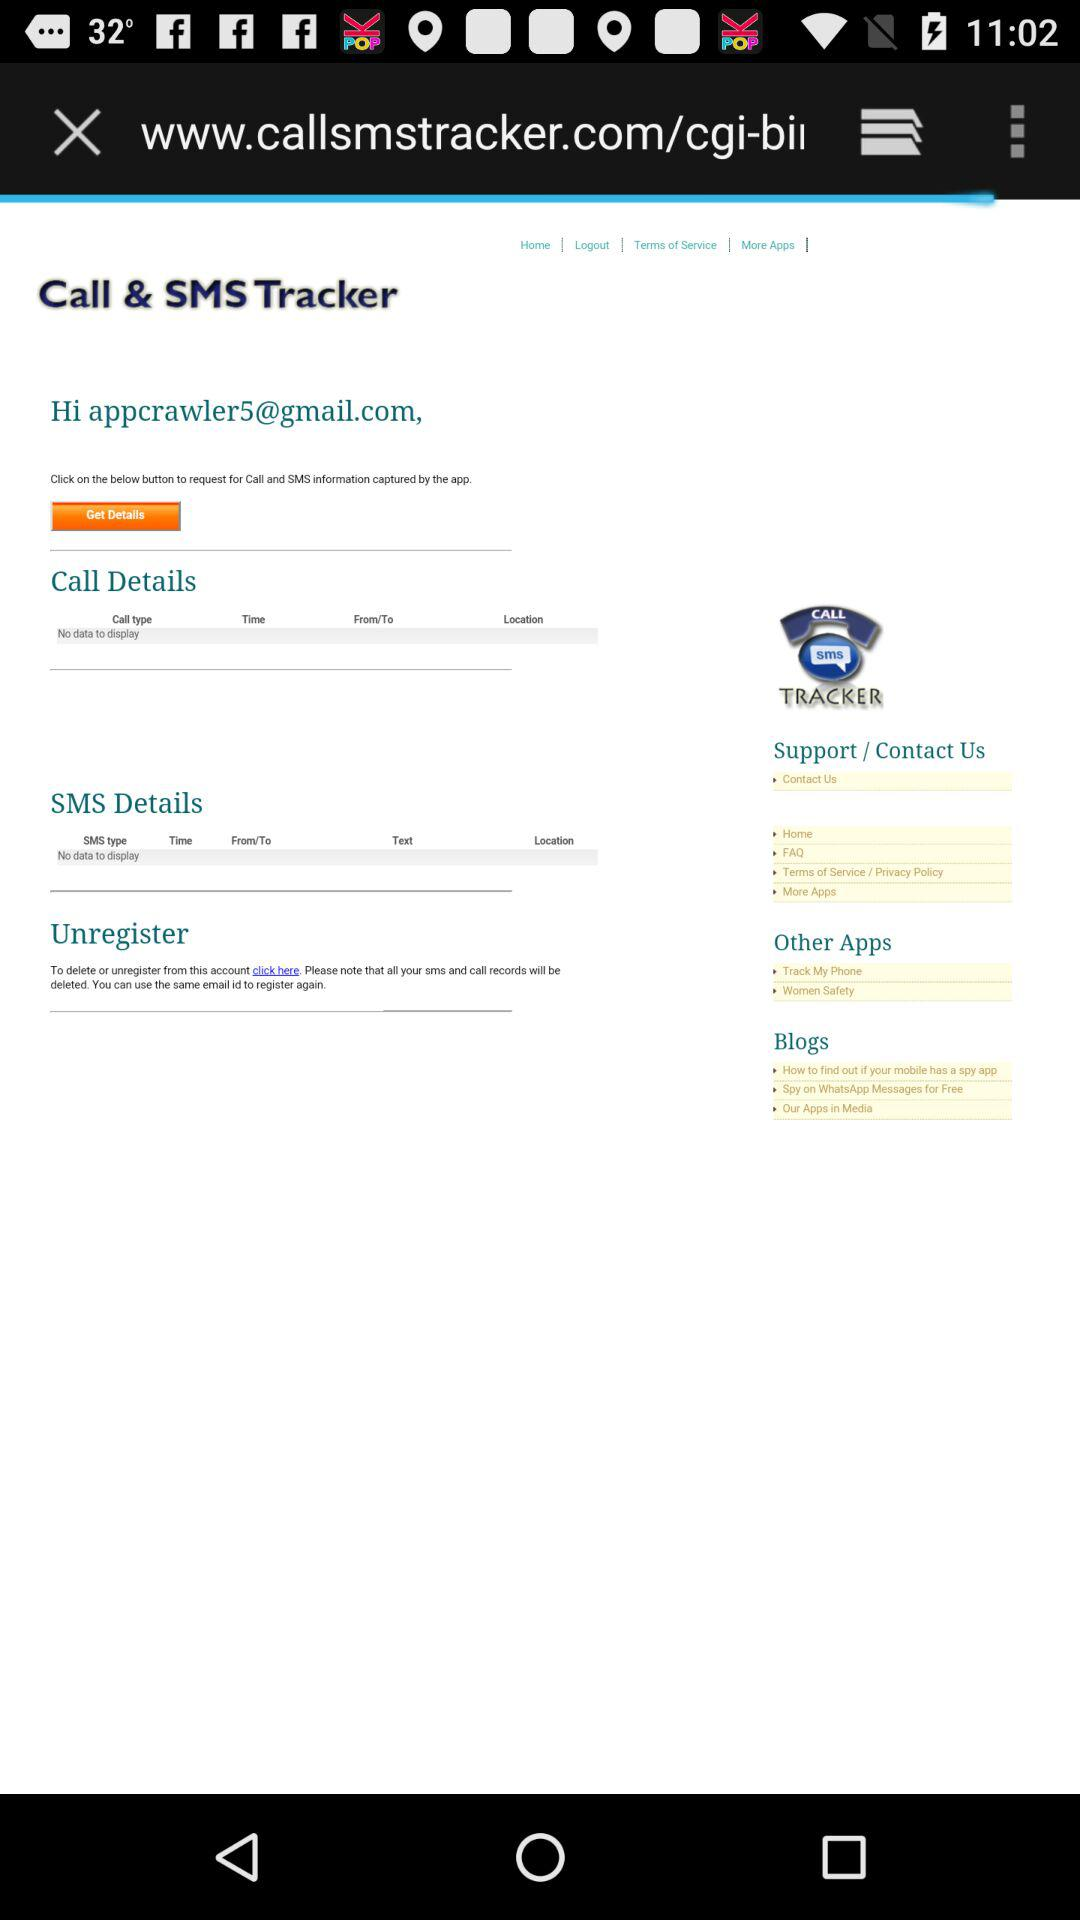What is the application name? The application name is "Call & SMS Tracker". 